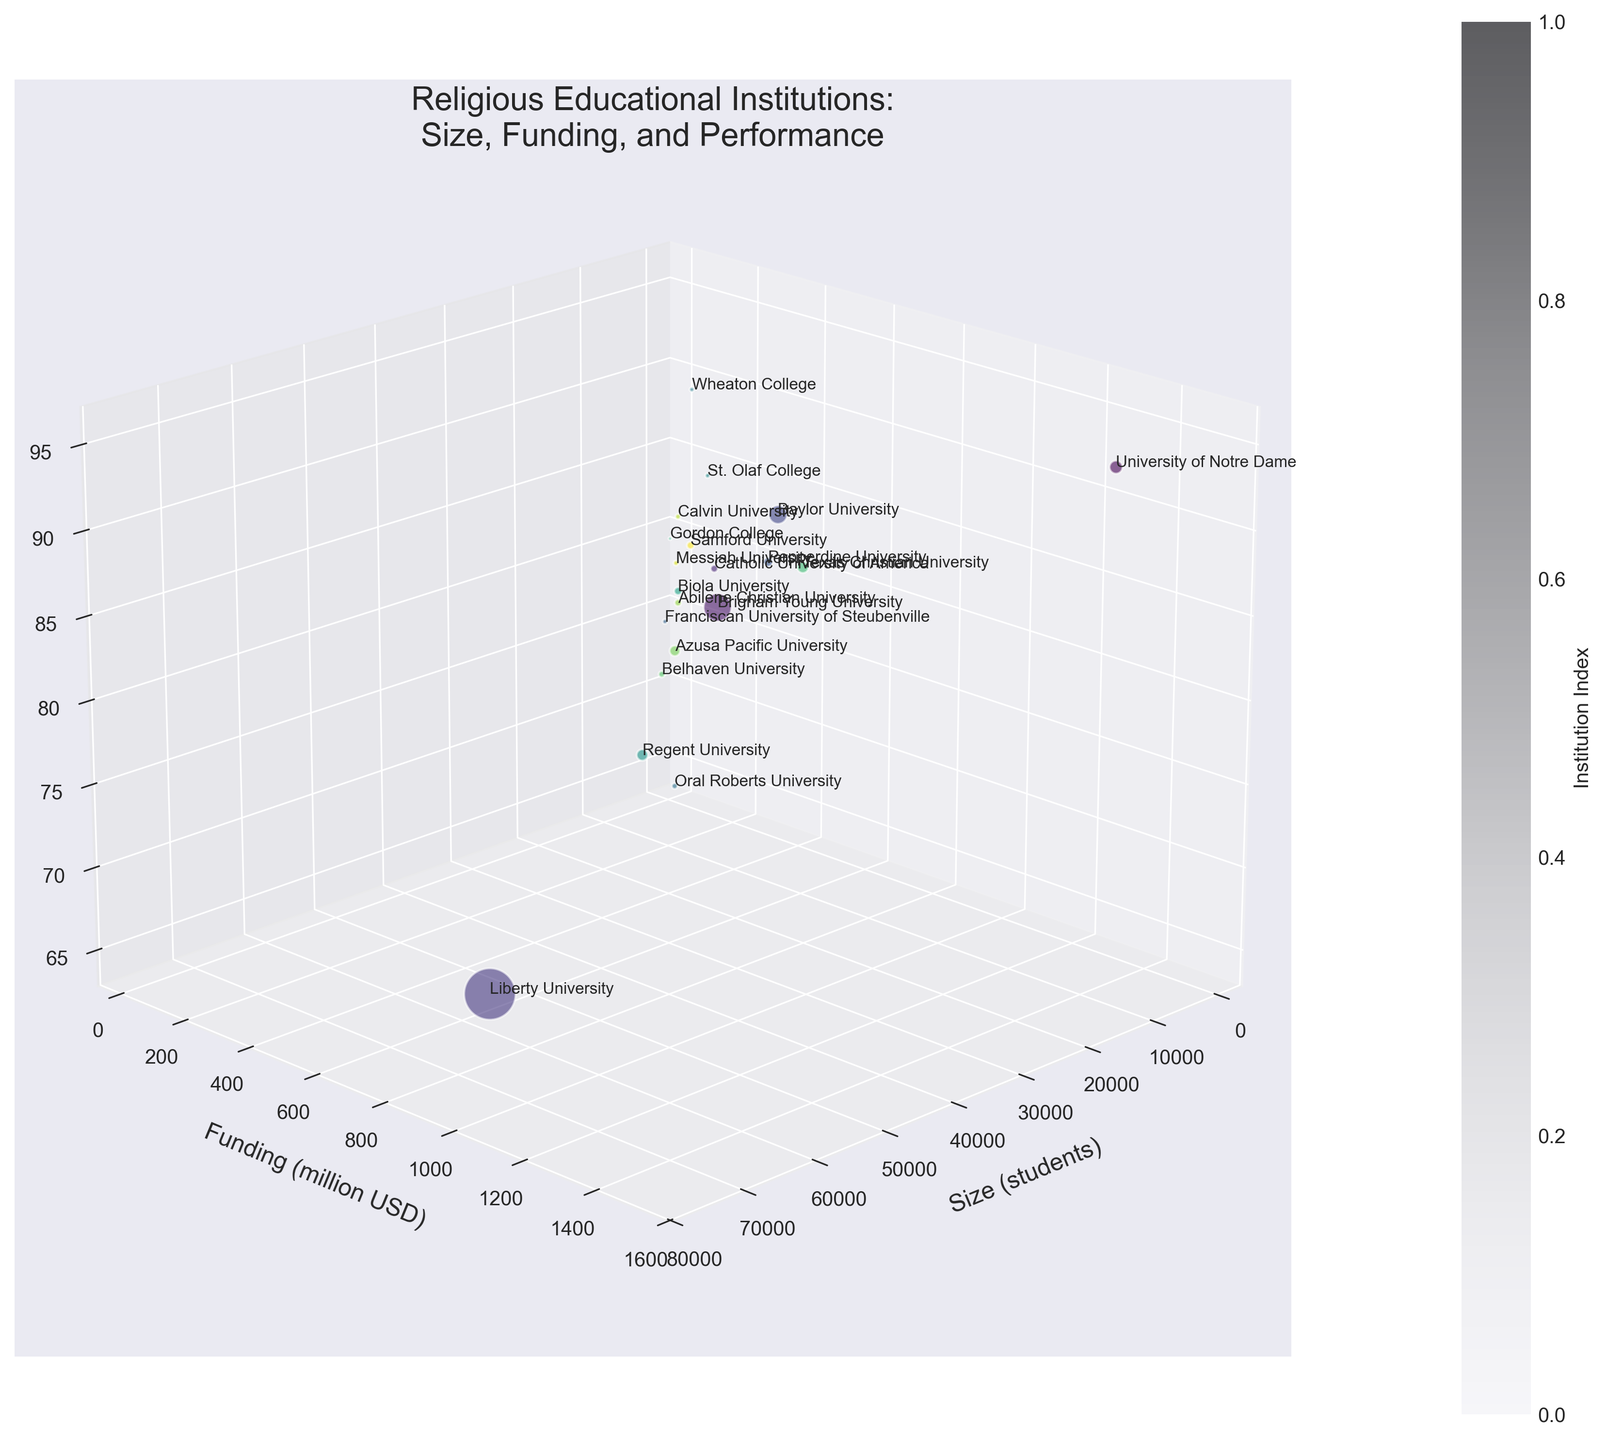What is the title of the chart? The title is located at the top of the chart, specifying the content of the figure. It usually provides an immediate understanding of what the chart is about. The title here is: "Religious Educational Institutions: Size, Funding, and Performance".
Answer: Religious Educational Institutions: Size, Funding, and Performance How many educational institutions are represented in the chart? Count the total number of bubbles (data points) in the 3D bubble chart to determine the number of institutions. Each bubble represents one institution.
Answer: 20 Which institution has the largest number of students? Look for the largest bubble along the Size axis (x-axis), where the size of each bubble is proportional to the number of students. The largest bubble should be identified as the institution with the most students.
Answer: Liberty University Which institution has the highest academic performance percentile? Identify the highest point along the Academic Performance axis (z-axis). Look for the bubble that is positioned highest in the chart.
Answer: University of Notre Dame Which two institutions have similar sizes but notable differences in funding? Find two bubbles that are close to each other along the Size axis (x-axis) but have bubbles with noticeably different positions along the Funding axis (y-axis).
Answer: Baylor University and Pepperdine University What is the relationship between academic performance and funding among these institutions? Analyze the placement of the bubbles along the Funding axis (y-axis) and Academic Performance axis (z-axis) to observe if there's any visual trend (e.g., do bubbles higher in funding tend to also be higher in performance?).
Answer: Generally positive; higher funding often correlates with higher academic performance Which institution has the smallest funding but a relatively high academic performance? Look for the bubble that is lowest along the Funding axis (y-axis) but comparatively higher along the Academic Performance axis (z-axis).
Answer: Franciscan University of Steubenville Considering both size and academic performance, which institution stands out the most? Evaluate the bubbles along both the Size axis (x-axis) and the Academic Performance axis (z-axis). Identify the institution with a large size and high academic performance percentile.
Answer: University of Notre Dame How does funding impact the sizes of the institutions in general? Considering both the Size (x-axis) and Funding (y-axis), examine if bubbles positioned with higher funding also tend to have larger sizes. Observe if there's a visible pattern or trend for these dimensions.
Answer: Larger institutions often have higher funding, but the relationship is not strict What color represents the institution index at the midpoint range in the dataset? Observe the color gradient of the bubbles, which represents different institution indices. Identify the color roughly at the middle of the gradient scale. This color corresponds to the halfway point index in the dataset.
Answer: Middle shade of the color gradient (greenish in the viridis colormap) 